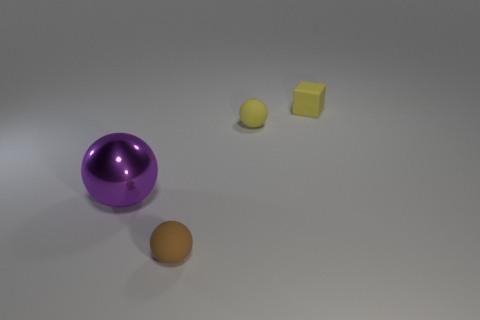Add 1 rubber spheres. How many objects exist? 5 Subtract all matte balls. How many balls are left? 1 Subtract all yellow spheres. How many spheres are left? 2 Subtract all spheres. How many objects are left? 1 Subtract all tiny brown rubber things. Subtract all cubes. How many objects are left? 2 Add 2 spheres. How many spheres are left? 5 Add 1 small brown metal balls. How many small brown metal balls exist? 1 Subtract 0 brown cylinders. How many objects are left? 4 Subtract 3 balls. How many balls are left? 0 Subtract all gray balls. Subtract all cyan blocks. How many balls are left? 3 